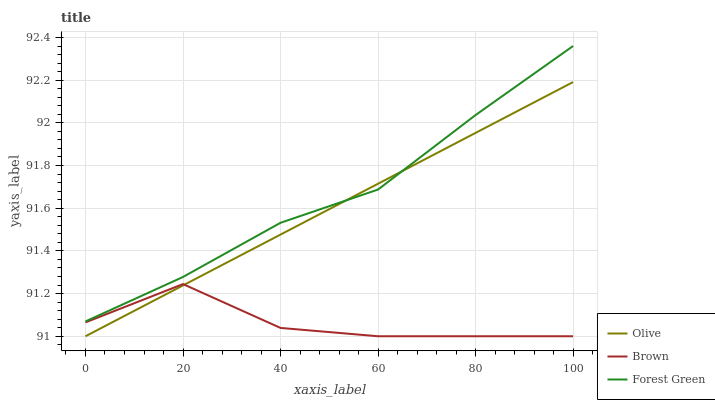Does Brown have the minimum area under the curve?
Answer yes or no. Yes. Does Forest Green have the maximum area under the curve?
Answer yes or no. Yes. Does Forest Green have the minimum area under the curve?
Answer yes or no. No. Does Brown have the maximum area under the curve?
Answer yes or no. No. Is Olive the smoothest?
Answer yes or no. Yes. Is Brown the roughest?
Answer yes or no. Yes. Is Forest Green the smoothest?
Answer yes or no. No. Is Forest Green the roughest?
Answer yes or no. No. Does Olive have the lowest value?
Answer yes or no. Yes. Does Forest Green have the lowest value?
Answer yes or no. No. Does Forest Green have the highest value?
Answer yes or no. Yes. Does Brown have the highest value?
Answer yes or no. No. Is Brown less than Forest Green?
Answer yes or no. Yes. Is Forest Green greater than Brown?
Answer yes or no. Yes. Does Brown intersect Olive?
Answer yes or no. Yes. Is Brown less than Olive?
Answer yes or no. No. Is Brown greater than Olive?
Answer yes or no. No. Does Brown intersect Forest Green?
Answer yes or no. No. 